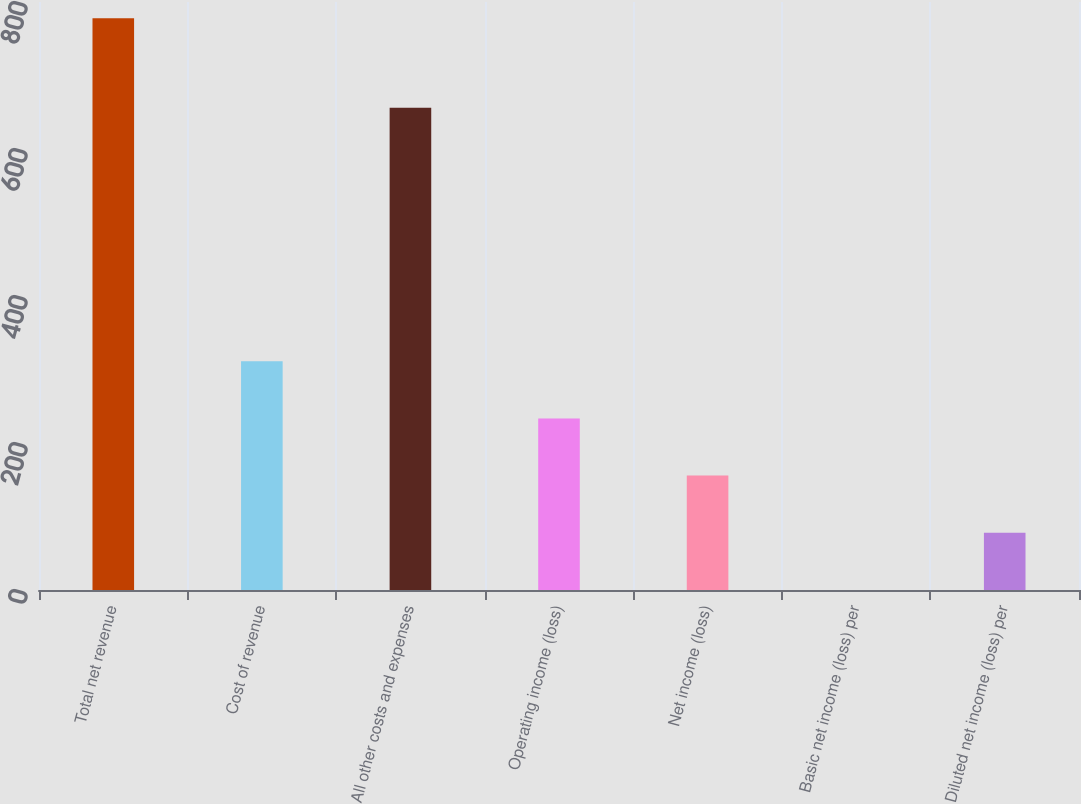Convert chart to OTSL. <chart><loc_0><loc_0><loc_500><loc_500><bar_chart><fcel>Total net revenue<fcel>Cost of revenue<fcel>All other costs and expenses<fcel>Operating income (loss)<fcel>Net income (loss)<fcel>Basic net income (loss) per<fcel>Diluted net income (loss) per<nl><fcel>778<fcel>311.28<fcel>656<fcel>233.49<fcel>155.7<fcel>0.12<fcel>77.91<nl></chart> 